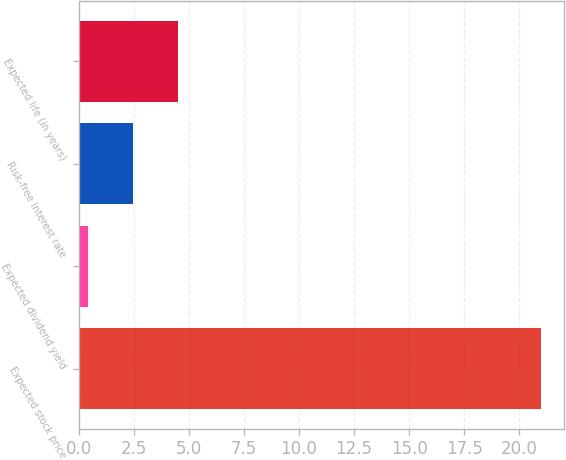<chart> <loc_0><loc_0><loc_500><loc_500><bar_chart><fcel>Expected stock price<fcel>Expected dividend yield<fcel>Risk-free interest rate<fcel>Expected life (in years)<nl><fcel>21<fcel>0.4<fcel>2.46<fcel>4.52<nl></chart> 